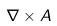<formula> <loc_0><loc_0><loc_500><loc_500>\nabla \times A</formula> 